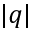<formula> <loc_0><loc_0><loc_500><loc_500>| q |</formula> 